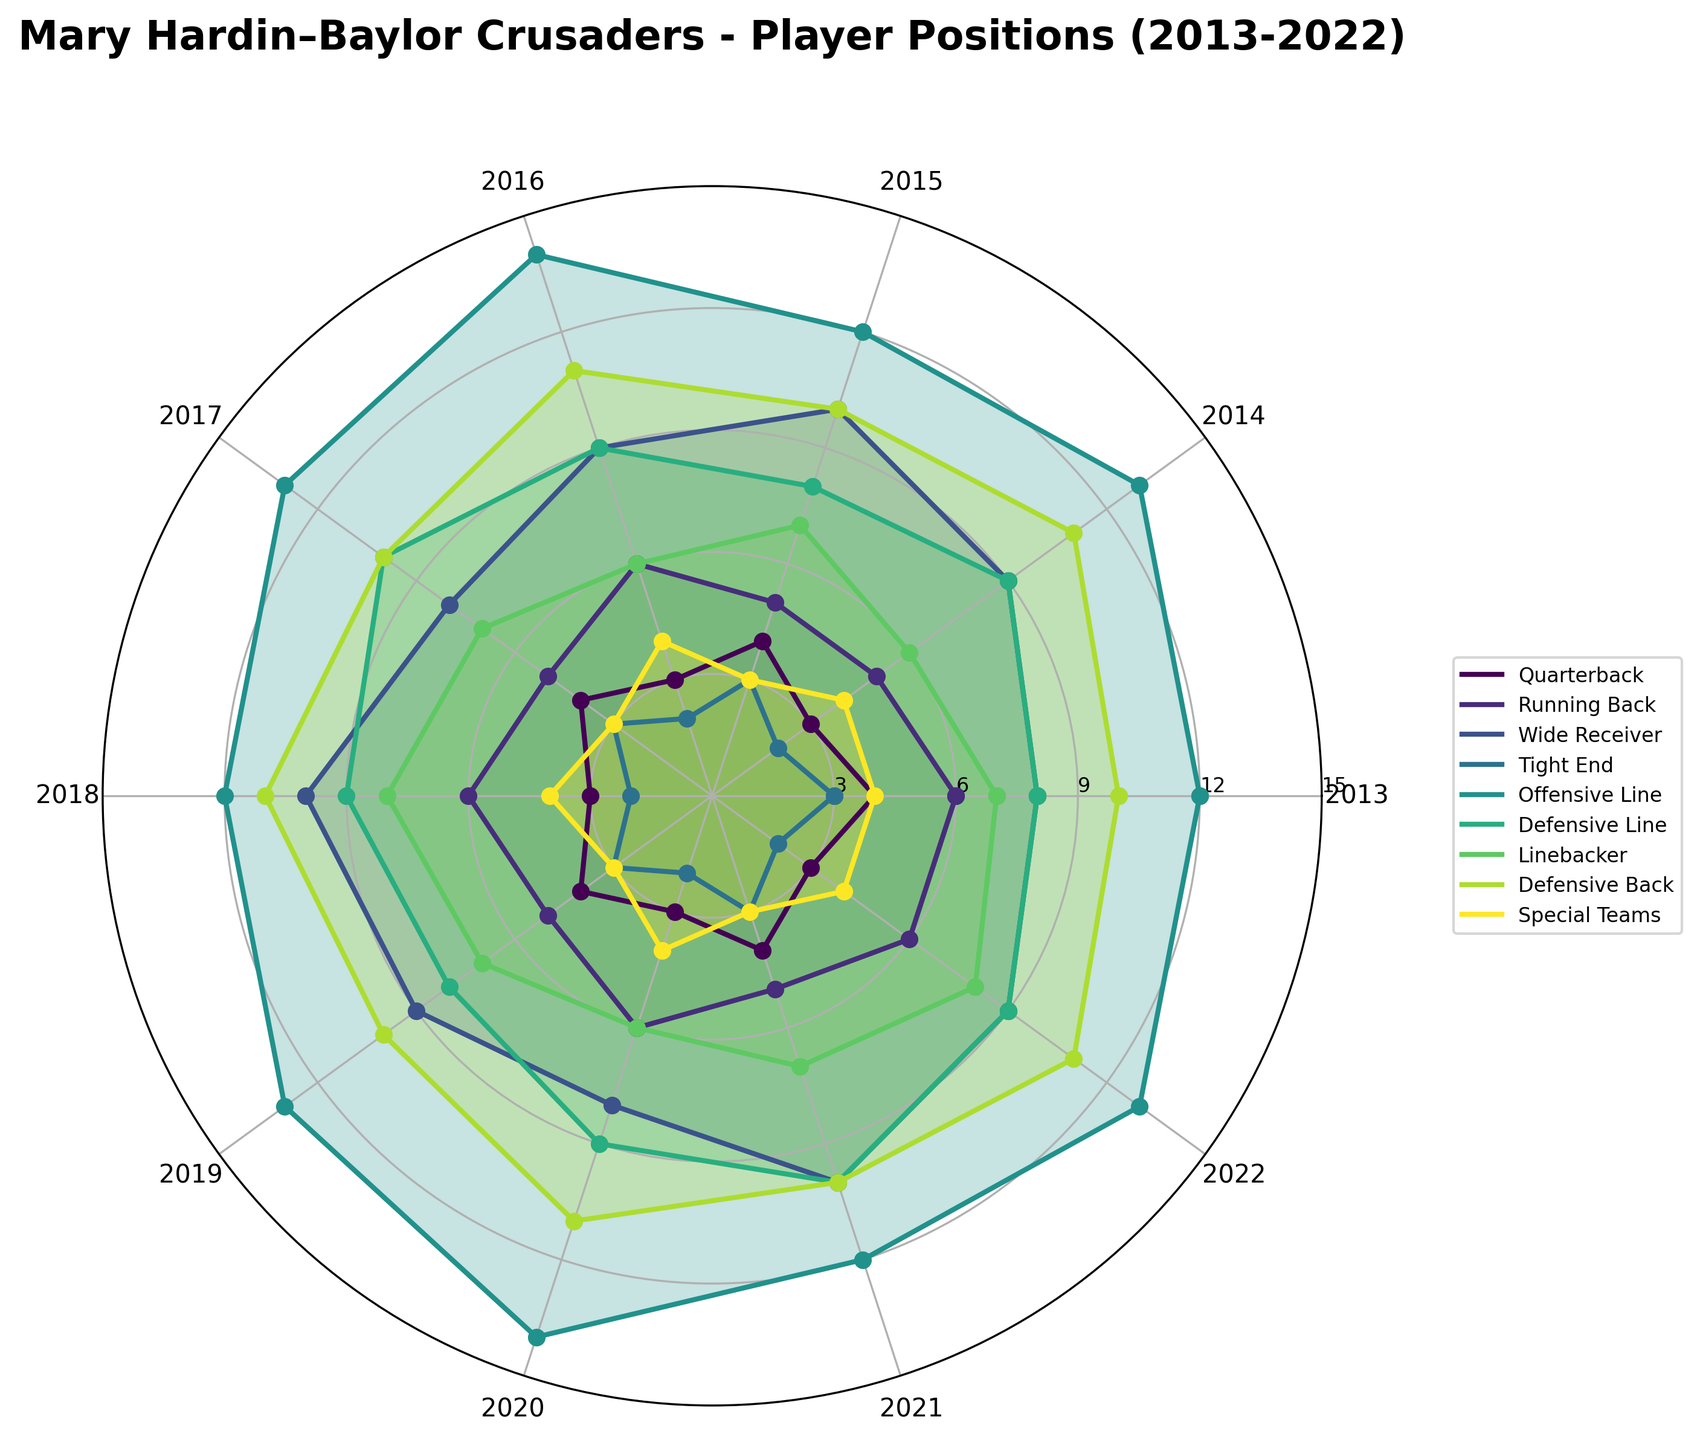What is the title of the figure? The title of the figure can be found at the top of the plot. It reads "Mary Hardin–Baylor Crusaders - Player Positions (2013-2022)".
Answer: Mary Hardin–Baylor Crusaders - Player Positions (2013-2022) Which player position had the highest number of players in 2020? By looking at the 2020 point on the plot, the tight ends (represented by different colored lines) can be identified. The Offensive Line is the highest in 2020.
Answer: Offensive Line How many quarterbacks were there in 2014? The number of quarterbacks for each year is plotted on the radial graph. In 2014, the value corresponding to the Quarterback line is 3.
Answer: 3 Which player position had the least number of players in 2018? By comparing the lines at the 2018 point on the plot, it can be observed that Tight End, with 2 players, has the least number.
Answer: Tight End Has the number of Defensive Line players increased or decreased from 2013 to 2022? Comparing the data points for Defensive Line in 2013 and 2022, the number of Defensive Line players has remained the same at 9.
Answer: Remained the same Which player position shows the most variability in the number of players over the decade? The variability can be observed visually by noting which line fluctuates the most over the period from 2013 to 2022. Wide Receiver shows significant ups and downs.
Answer: Wide Receiver What was the average number of Running Backs per year between 2013 and 2022? Sum the values for Running Backs for each year and then divide by the number of years (10). \( \frac{6+5+5+6+5+6+5+6+5+6}{10} \) = 5.5
Answer: 5.5 Which two years had the same number of total players for the Offensive Line? By comparing the points for Offensive Line across the years, 2015 and 2018 both have 12 Offensive Line players.
Answer: 2015 and 2018 What is the trend for the number of Linebackers from 2013 to 2022? Observing the line corresponding to Linebackers from 2013 to 2022 shows slight fluctuations but remains relatively consistent.
Answer: Relatively consistent Between which two adjacent years did the number of Wide Receivers increase the most? Observing the changes in Wide Receivers between adjacent years, the largest increase is between 2017 and 2018, rising from 8 to 10.
Answer: 2017 and 2018 